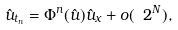<formula> <loc_0><loc_0><loc_500><loc_500>\hat { u } _ { t _ { n } } = \Phi ^ { n } ( \hat { u } ) \hat { u } _ { x } + o ( \ 2 ^ { N } ) ,</formula> 